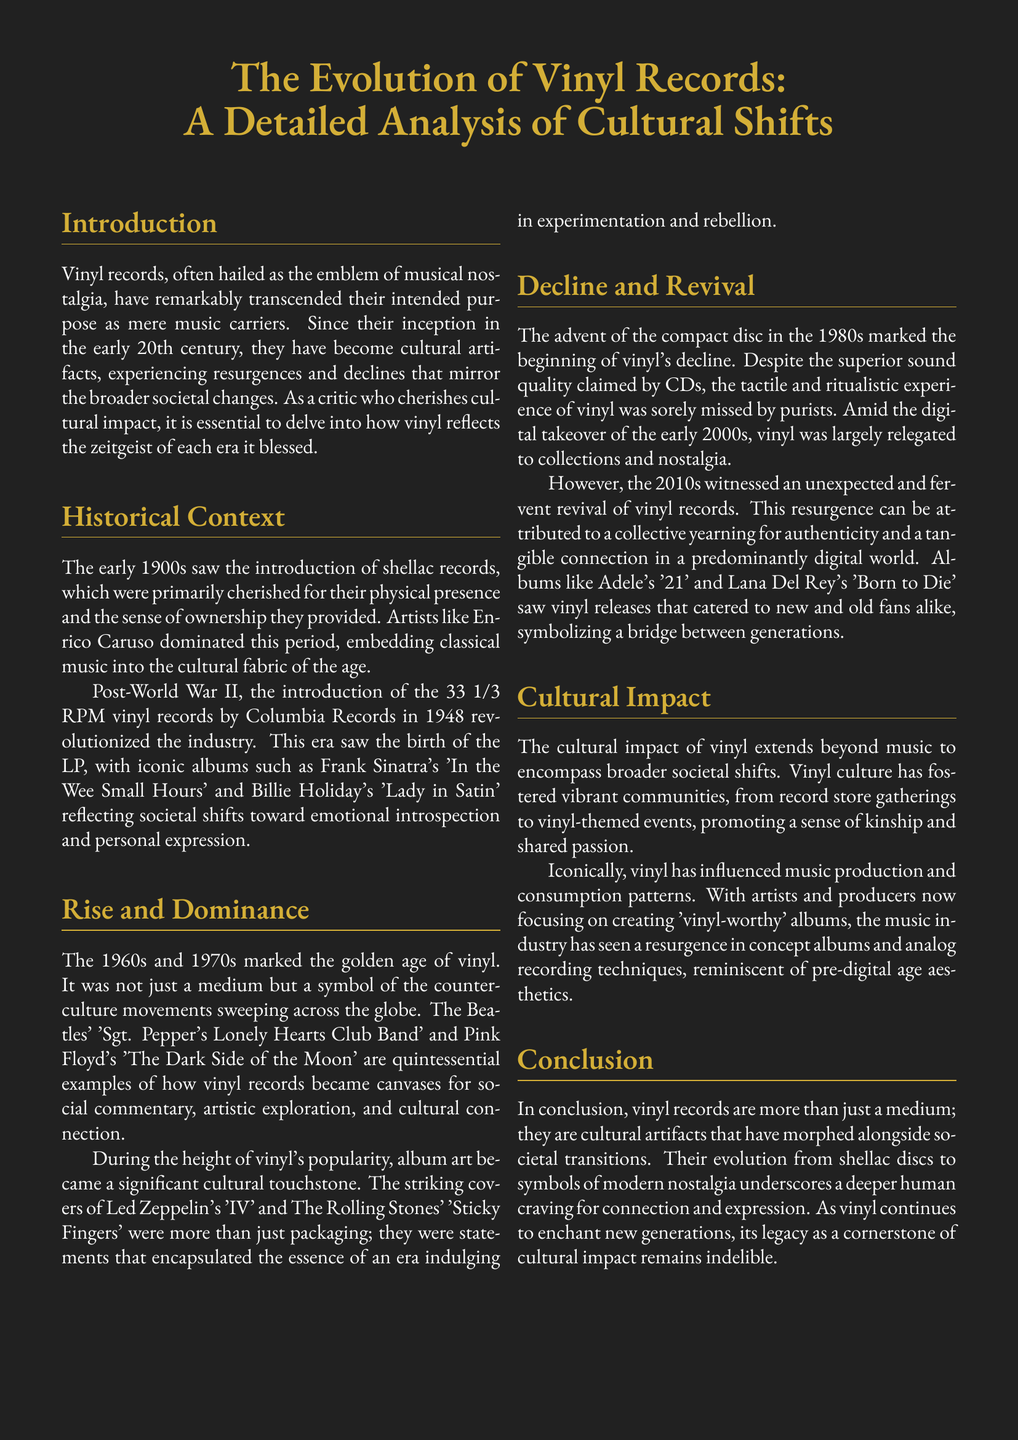What year was the 33 1/3 RPM vinyl record introduced? The document states that the 33 1/3 RPM vinyl records were introduced by Columbia Records in 1948.
Answer: 1948 Which artist's album is mentioned as reflecting emotional introspection? The document references Frank Sinatra's album 'In the Wee Small Hours' as an example of emotional introspection and personal expression.
Answer: 'In the Wee Small Hours' What marked the golden age of vinyl? The golden age of vinyl is marked by the 1960s and 1970s when it became a symbol of counter-culture movements.
Answer: 1960s and 1970s What is one reason for the vinyl revival in the 2010s? According to the document, one reason for the revival was a collective yearning for authenticity and a tangible connection in a digital world.
Answer: Authenticity Which album by The Beatles is considered iconic in vinyl culture? The document mentions 'Sgt. Pepper's Lonely Hearts Club Band' as an iconic vinyl album from the 1960s.
Answer: 'Sgt. Pepper's Lonely Hearts Club Band' What impact did vinyl records have on music production? The document notes that vinyl has influenced artists and producers to focus on creating 'vinyl-worthy' albums and concept albums.
Answer: 'Vinyl-worthy' albums What type of gatherings have been fostered by vinyl culture? Vinyl culture has fostered communities, promoting gatherings such as record store meetings and vinyl-themed events.
Answer: Record store gatherings What does the conclusion state about the legacy of vinyl records? The conclusion emphasizes that the legacy of vinyl records as a cornerstone of cultural impact remains indelible.
Answer: Indelible 